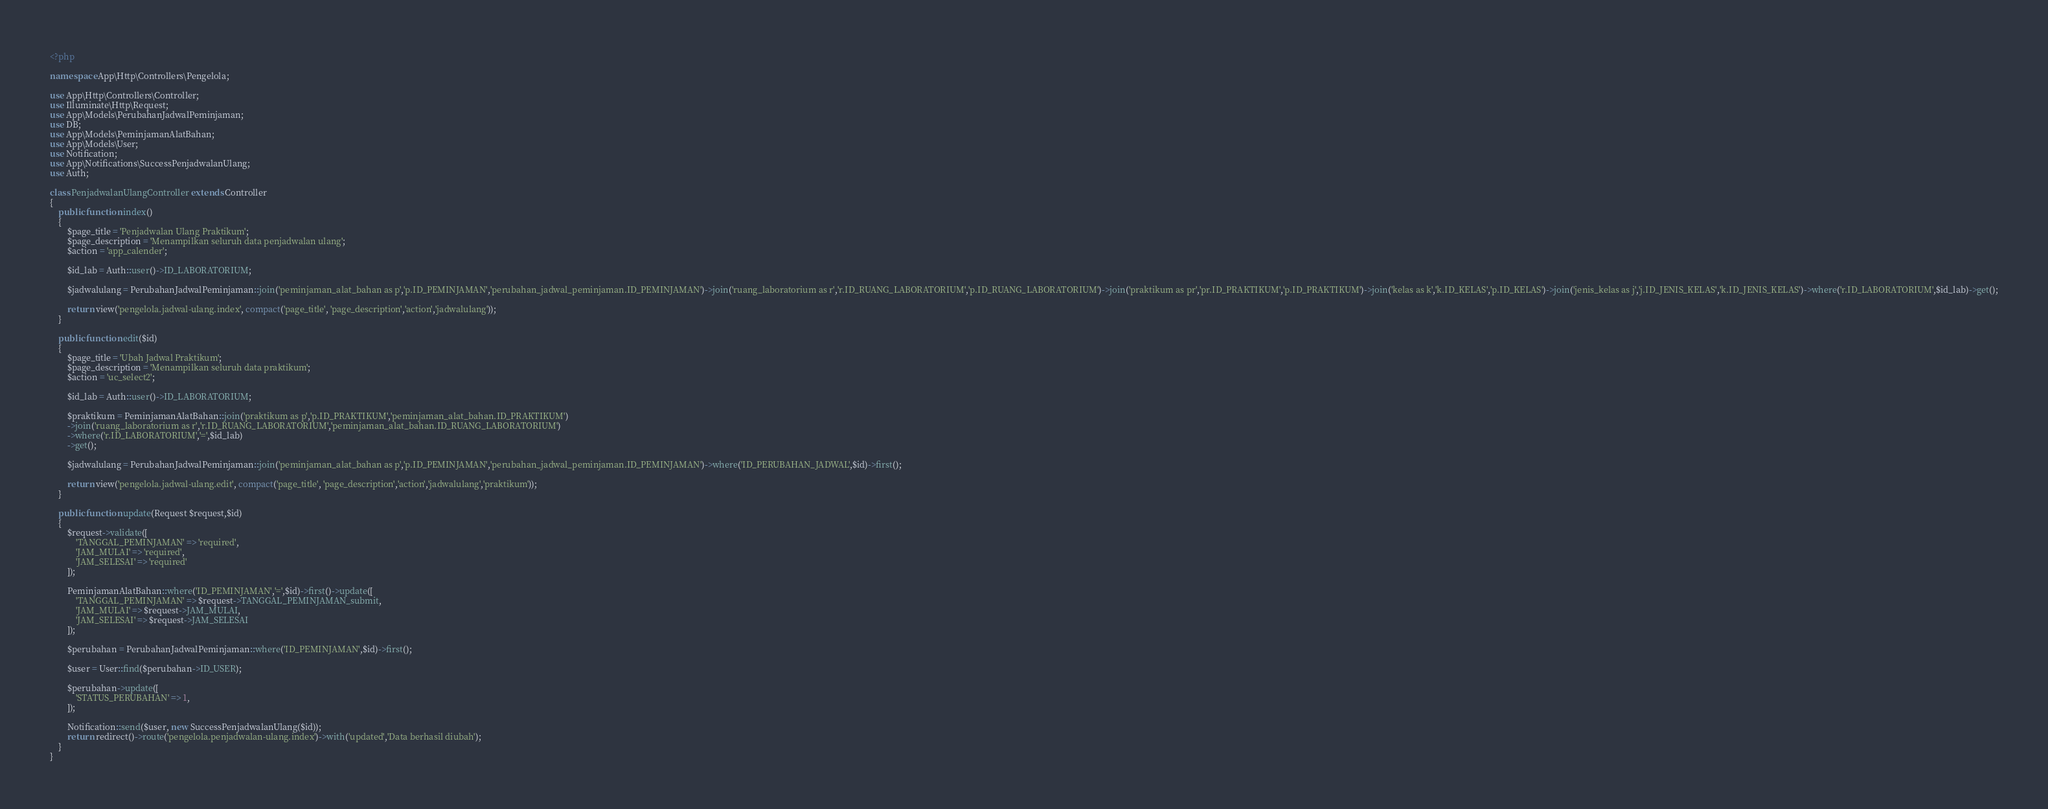Convert code to text. <code><loc_0><loc_0><loc_500><loc_500><_PHP_><?php

namespace App\Http\Controllers\Pengelola;

use App\Http\Controllers\Controller;
use Illuminate\Http\Request;
use App\Models\PerubahanJadwalPeminjaman;
use DB;
use App\Models\PeminjamanAlatBahan;
use App\Models\User;
use Notification;
use App\Notifications\SuccessPenjadwalanUlang;
use Auth;

class PenjadwalanUlangController extends Controller
{
    public function index()
    {
        $page_title = 'Penjadwalan Ulang Praktikum';
        $page_description = 'Menampilkan seluruh data penjadwalan ulang';
        $action = 'app_calender';

        $id_lab = Auth::user()->ID_LABORATORIUM;

        $jadwalulang = PerubahanJadwalPeminjaman::join('peminjaman_alat_bahan as p','p.ID_PEMINJAMAN','perubahan_jadwal_peminjaman.ID_PEMINJAMAN')->join('ruang_laboratorium as r','r.ID_RUANG_LABORATORIUM','p.ID_RUANG_LABORATORIUM')->join('praktikum as pr','pr.ID_PRAKTIKUM','p.ID_PRAKTIKUM')->join('kelas as k','k.ID_KELAS','p.ID_KELAS')->join('jenis_kelas as j','j.ID_JENIS_KELAS','k.ID_JENIS_KELAS')->where('r.ID_LABORATORIUM',$id_lab)->get();

        return view('pengelola.jadwal-ulang.index', compact('page_title', 'page_description','action','jadwalulang'));
    }

    public function edit($id)
    {
        $page_title = 'Ubah Jadwal Praktikum';
        $page_description = 'Menampilkan seluruh data praktikum';
        $action = 'uc_select2';

        $id_lab = Auth::user()->ID_LABORATORIUM;

        $praktikum = PeminjamanAlatBahan::join('praktikum as p','p.ID_PRAKTIKUM','peminjaman_alat_bahan.ID_PRAKTIKUM')
        ->join('ruang_laboratorium as r','r.ID_RUANG_LABORATORIUM','peminjaman_alat_bahan.ID_RUANG_LABORATORIUM')
        ->where('r.ID_LABORATORIUM','=',$id_lab)
        ->get();

        $jadwalulang = PerubahanJadwalPeminjaman::join('peminjaman_alat_bahan as p','p.ID_PEMINJAMAN','perubahan_jadwal_peminjaman.ID_PEMINJAMAN')->where('ID_PERUBAHAN_JADWAL',$id)->first();

        return view('pengelola.jadwal-ulang.edit', compact('page_title', 'page_description','action','jadwalulang','praktikum'));
    }

    public function update(Request $request,$id)
    {
        $request->validate([
            'TANGGAL_PEMINJAMAN' => 'required',
            'JAM_MULAI' => 'required',
            'JAM_SELESAI' => 'required'
        ]);
        
        PeminjamanAlatBahan::where('ID_PEMINJAMAN','=',$id)->first()->update([
            'TANGGAL_PEMINJAMAN' => $request->TANGGAL_PEMINJAMAN_submit,
            'JAM_MULAI' => $request->JAM_MULAI,
            'JAM_SELESAI' => $request->JAM_SELESAI
        ]);

        $perubahan = PerubahanJadwalPeminjaman::where('ID_PEMINJAMAN',$id)->first();

        $user = User::find($perubahan->ID_USER);

        $perubahan->update([
            'STATUS_PERUBAHAN' => 1,
        ]);

        Notification::send($user, new SuccessPenjadwalanUlang($id));
        return redirect()->route('pengelola.penjadwalan-ulang.index')->with('updated','Data berhasil diubah');
    }
}
</code> 